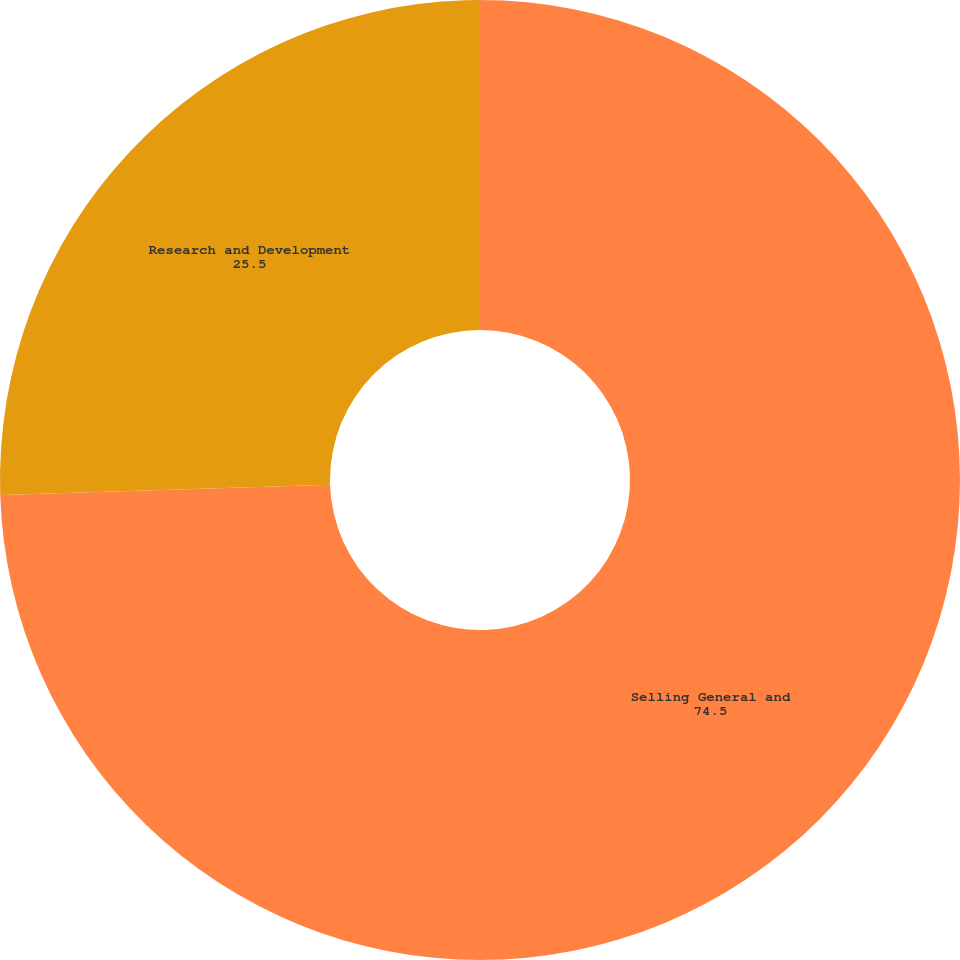Convert chart. <chart><loc_0><loc_0><loc_500><loc_500><pie_chart><fcel>Selling General and<fcel>Research and Development<nl><fcel>74.5%<fcel>25.5%<nl></chart> 